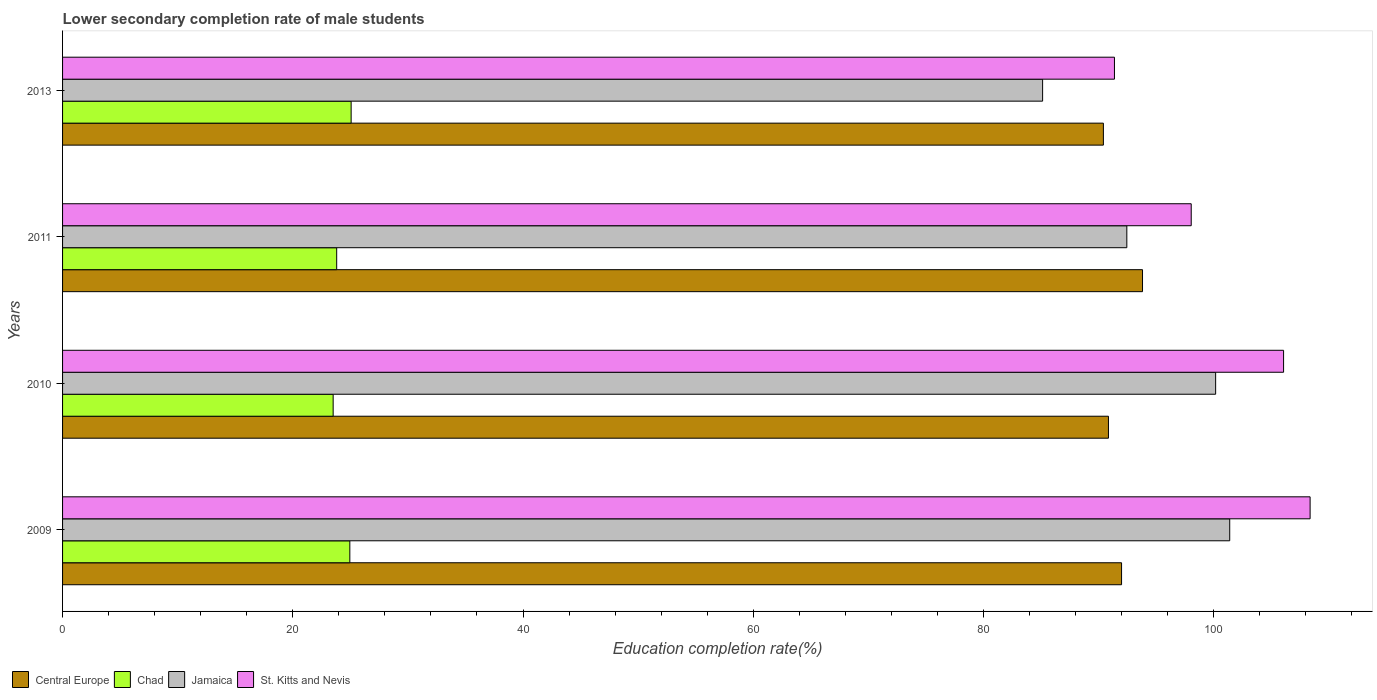How many groups of bars are there?
Your answer should be very brief. 4. How many bars are there on the 4th tick from the top?
Offer a terse response. 4. How many bars are there on the 2nd tick from the bottom?
Offer a very short reply. 4. What is the lower secondary completion rate of male students in St. Kitts and Nevis in 2013?
Keep it short and to the point. 91.38. Across all years, what is the maximum lower secondary completion rate of male students in St. Kitts and Nevis?
Offer a terse response. 108.37. Across all years, what is the minimum lower secondary completion rate of male students in St. Kitts and Nevis?
Keep it short and to the point. 91.38. What is the total lower secondary completion rate of male students in Central Europe in the graph?
Your answer should be compact. 367.07. What is the difference between the lower secondary completion rate of male students in Chad in 2010 and that in 2013?
Make the answer very short. -1.56. What is the difference between the lower secondary completion rate of male students in St. Kitts and Nevis in 2010 and the lower secondary completion rate of male students in Chad in 2009?
Provide a succinct answer. 81.11. What is the average lower secondary completion rate of male students in Chad per year?
Your response must be concise. 24.33. In the year 2009, what is the difference between the lower secondary completion rate of male students in St. Kitts and Nevis and lower secondary completion rate of male students in Chad?
Offer a very short reply. 83.42. What is the ratio of the lower secondary completion rate of male students in St. Kitts and Nevis in 2010 to that in 2011?
Make the answer very short. 1.08. Is the lower secondary completion rate of male students in Chad in 2009 less than that in 2013?
Your answer should be very brief. Yes. What is the difference between the highest and the second highest lower secondary completion rate of male students in Jamaica?
Your response must be concise. 1.22. What is the difference between the highest and the lowest lower secondary completion rate of male students in Chad?
Your answer should be very brief. 1.56. In how many years, is the lower secondary completion rate of male students in Central Europe greater than the average lower secondary completion rate of male students in Central Europe taken over all years?
Make the answer very short. 2. Is it the case that in every year, the sum of the lower secondary completion rate of male students in Central Europe and lower secondary completion rate of male students in Chad is greater than the sum of lower secondary completion rate of male students in St. Kitts and Nevis and lower secondary completion rate of male students in Jamaica?
Give a very brief answer. Yes. What does the 4th bar from the top in 2009 represents?
Provide a short and direct response. Central Europe. What does the 1st bar from the bottom in 2010 represents?
Your answer should be compact. Central Europe. Is it the case that in every year, the sum of the lower secondary completion rate of male students in Jamaica and lower secondary completion rate of male students in Chad is greater than the lower secondary completion rate of male students in St. Kitts and Nevis?
Offer a very short reply. Yes. How many bars are there?
Your answer should be very brief. 16. Are all the bars in the graph horizontal?
Provide a short and direct response. Yes. What is the difference between two consecutive major ticks on the X-axis?
Provide a succinct answer. 20. Does the graph contain any zero values?
Provide a short and direct response. No. Does the graph contain grids?
Provide a succinct answer. No. How many legend labels are there?
Keep it short and to the point. 4. How are the legend labels stacked?
Your answer should be very brief. Horizontal. What is the title of the graph?
Your response must be concise. Lower secondary completion rate of male students. What is the label or title of the X-axis?
Provide a short and direct response. Education completion rate(%). What is the label or title of the Y-axis?
Make the answer very short. Years. What is the Education completion rate(%) in Central Europe in 2009?
Offer a very short reply. 91.99. What is the Education completion rate(%) in Chad in 2009?
Make the answer very short. 24.95. What is the Education completion rate(%) of Jamaica in 2009?
Offer a terse response. 101.39. What is the Education completion rate(%) of St. Kitts and Nevis in 2009?
Keep it short and to the point. 108.37. What is the Education completion rate(%) of Central Europe in 2010?
Your answer should be compact. 90.85. What is the Education completion rate(%) of Chad in 2010?
Offer a very short reply. 23.51. What is the Education completion rate(%) of Jamaica in 2010?
Your answer should be very brief. 100.17. What is the Education completion rate(%) of St. Kitts and Nevis in 2010?
Make the answer very short. 106.07. What is the Education completion rate(%) of Central Europe in 2011?
Keep it short and to the point. 93.81. What is the Education completion rate(%) of Chad in 2011?
Your answer should be very brief. 23.81. What is the Education completion rate(%) of Jamaica in 2011?
Your answer should be compact. 92.45. What is the Education completion rate(%) in St. Kitts and Nevis in 2011?
Ensure brevity in your answer.  98.04. What is the Education completion rate(%) of Central Europe in 2013?
Ensure brevity in your answer.  90.41. What is the Education completion rate(%) in Chad in 2013?
Give a very brief answer. 25.07. What is the Education completion rate(%) in Jamaica in 2013?
Keep it short and to the point. 85.13. What is the Education completion rate(%) of St. Kitts and Nevis in 2013?
Your answer should be very brief. 91.38. Across all years, what is the maximum Education completion rate(%) in Central Europe?
Your answer should be very brief. 93.81. Across all years, what is the maximum Education completion rate(%) in Chad?
Offer a very short reply. 25.07. Across all years, what is the maximum Education completion rate(%) of Jamaica?
Give a very brief answer. 101.39. Across all years, what is the maximum Education completion rate(%) of St. Kitts and Nevis?
Provide a succinct answer. 108.37. Across all years, what is the minimum Education completion rate(%) of Central Europe?
Provide a short and direct response. 90.41. Across all years, what is the minimum Education completion rate(%) in Chad?
Ensure brevity in your answer.  23.51. Across all years, what is the minimum Education completion rate(%) of Jamaica?
Your answer should be very brief. 85.13. Across all years, what is the minimum Education completion rate(%) in St. Kitts and Nevis?
Your response must be concise. 91.38. What is the total Education completion rate(%) of Central Europe in the graph?
Offer a very short reply. 367.07. What is the total Education completion rate(%) of Chad in the graph?
Ensure brevity in your answer.  97.34. What is the total Education completion rate(%) in Jamaica in the graph?
Offer a terse response. 379.14. What is the total Education completion rate(%) in St. Kitts and Nevis in the graph?
Keep it short and to the point. 403.86. What is the difference between the Education completion rate(%) of Central Europe in 2009 and that in 2010?
Make the answer very short. 1.14. What is the difference between the Education completion rate(%) in Chad in 2009 and that in 2010?
Give a very brief answer. 1.45. What is the difference between the Education completion rate(%) of Jamaica in 2009 and that in 2010?
Your answer should be compact. 1.22. What is the difference between the Education completion rate(%) in St. Kitts and Nevis in 2009 and that in 2010?
Offer a very short reply. 2.3. What is the difference between the Education completion rate(%) of Central Europe in 2009 and that in 2011?
Keep it short and to the point. -1.82. What is the difference between the Education completion rate(%) of Chad in 2009 and that in 2011?
Offer a very short reply. 1.14. What is the difference between the Education completion rate(%) of Jamaica in 2009 and that in 2011?
Your answer should be compact. 8.94. What is the difference between the Education completion rate(%) of St. Kitts and Nevis in 2009 and that in 2011?
Ensure brevity in your answer.  10.33. What is the difference between the Education completion rate(%) of Central Europe in 2009 and that in 2013?
Keep it short and to the point. 1.58. What is the difference between the Education completion rate(%) of Chad in 2009 and that in 2013?
Provide a short and direct response. -0.11. What is the difference between the Education completion rate(%) in Jamaica in 2009 and that in 2013?
Give a very brief answer. 16.25. What is the difference between the Education completion rate(%) in St. Kitts and Nevis in 2009 and that in 2013?
Your answer should be compact. 17. What is the difference between the Education completion rate(%) in Central Europe in 2010 and that in 2011?
Keep it short and to the point. -2.96. What is the difference between the Education completion rate(%) in Chad in 2010 and that in 2011?
Give a very brief answer. -0.31. What is the difference between the Education completion rate(%) in Jamaica in 2010 and that in 2011?
Give a very brief answer. 7.71. What is the difference between the Education completion rate(%) in St. Kitts and Nevis in 2010 and that in 2011?
Offer a terse response. 8.02. What is the difference between the Education completion rate(%) of Central Europe in 2010 and that in 2013?
Offer a terse response. 0.44. What is the difference between the Education completion rate(%) in Chad in 2010 and that in 2013?
Keep it short and to the point. -1.56. What is the difference between the Education completion rate(%) of Jamaica in 2010 and that in 2013?
Offer a terse response. 15.03. What is the difference between the Education completion rate(%) of St. Kitts and Nevis in 2010 and that in 2013?
Provide a succinct answer. 14.69. What is the difference between the Education completion rate(%) of Central Europe in 2011 and that in 2013?
Your answer should be very brief. 3.4. What is the difference between the Education completion rate(%) of Chad in 2011 and that in 2013?
Offer a very short reply. -1.26. What is the difference between the Education completion rate(%) of Jamaica in 2011 and that in 2013?
Keep it short and to the point. 7.32. What is the difference between the Education completion rate(%) in St. Kitts and Nevis in 2011 and that in 2013?
Offer a terse response. 6.67. What is the difference between the Education completion rate(%) of Central Europe in 2009 and the Education completion rate(%) of Chad in 2010?
Give a very brief answer. 68.49. What is the difference between the Education completion rate(%) in Central Europe in 2009 and the Education completion rate(%) in Jamaica in 2010?
Give a very brief answer. -8.17. What is the difference between the Education completion rate(%) in Central Europe in 2009 and the Education completion rate(%) in St. Kitts and Nevis in 2010?
Ensure brevity in your answer.  -14.07. What is the difference between the Education completion rate(%) of Chad in 2009 and the Education completion rate(%) of Jamaica in 2010?
Your response must be concise. -75.21. What is the difference between the Education completion rate(%) in Chad in 2009 and the Education completion rate(%) in St. Kitts and Nevis in 2010?
Offer a very short reply. -81.11. What is the difference between the Education completion rate(%) in Jamaica in 2009 and the Education completion rate(%) in St. Kitts and Nevis in 2010?
Your answer should be very brief. -4.68. What is the difference between the Education completion rate(%) of Central Europe in 2009 and the Education completion rate(%) of Chad in 2011?
Give a very brief answer. 68.18. What is the difference between the Education completion rate(%) of Central Europe in 2009 and the Education completion rate(%) of Jamaica in 2011?
Provide a succinct answer. -0.46. What is the difference between the Education completion rate(%) in Central Europe in 2009 and the Education completion rate(%) in St. Kitts and Nevis in 2011?
Your response must be concise. -6.05. What is the difference between the Education completion rate(%) in Chad in 2009 and the Education completion rate(%) in Jamaica in 2011?
Your response must be concise. -67.5. What is the difference between the Education completion rate(%) of Chad in 2009 and the Education completion rate(%) of St. Kitts and Nevis in 2011?
Your response must be concise. -73.09. What is the difference between the Education completion rate(%) in Jamaica in 2009 and the Education completion rate(%) in St. Kitts and Nevis in 2011?
Ensure brevity in your answer.  3.34. What is the difference between the Education completion rate(%) of Central Europe in 2009 and the Education completion rate(%) of Chad in 2013?
Make the answer very short. 66.93. What is the difference between the Education completion rate(%) in Central Europe in 2009 and the Education completion rate(%) in Jamaica in 2013?
Ensure brevity in your answer.  6.86. What is the difference between the Education completion rate(%) of Central Europe in 2009 and the Education completion rate(%) of St. Kitts and Nevis in 2013?
Provide a short and direct response. 0.62. What is the difference between the Education completion rate(%) of Chad in 2009 and the Education completion rate(%) of Jamaica in 2013?
Provide a short and direct response. -60.18. What is the difference between the Education completion rate(%) in Chad in 2009 and the Education completion rate(%) in St. Kitts and Nevis in 2013?
Provide a succinct answer. -66.42. What is the difference between the Education completion rate(%) in Jamaica in 2009 and the Education completion rate(%) in St. Kitts and Nevis in 2013?
Your answer should be compact. 10.01. What is the difference between the Education completion rate(%) in Central Europe in 2010 and the Education completion rate(%) in Chad in 2011?
Give a very brief answer. 67.04. What is the difference between the Education completion rate(%) in Central Europe in 2010 and the Education completion rate(%) in Jamaica in 2011?
Provide a short and direct response. -1.6. What is the difference between the Education completion rate(%) in Central Europe in 2010 and the Education completion rate(%) in St. Kitts and Nevis in 2011?
Make the answer very short. -7.19. What is the difference between the Education completion rate(%) in Chad in 2010 and the Education completion rate(%) in Jamaica in 2011?
Ensure brevity in your answer.  -68.95. What is the difference between the Education completion rate(%) of Chad in 2010 and the Education completion rate(%) of St. Kitts and Nevis in 2011?
Provide a succinct answer. -74.54. What is the difference between the Education completion rate(%) of Jamaica in 2010 and the Education completion rate(%) of St. Kitts and Nevis in 2011?
Your answer should be compact. 2.12. What is the difference between the Education completion rate(%) of Central Europe in 2010 and the Education completion rate(%) of Chad in 2013?
Your response must be concise. 65.79. What is the difference between the Education completion rate(%) of Central Europe in 2010 and the Education completion rate(%) of Jamaica in 2013?
Keep it short and to the point. 5.72. What is the difference between the Education completion rate(%) in Central Europe in 2010 and the Education completion rate(%) in St. Kitts and Nevis in 2013?
Provide a succinct answer. -0.52. What is the difference between the Education completion rate(%) in Chad in 2010 and the Education completion rate(%) in Jamaica in 2013?
Your response must be concise. -61.63. What is the difference between the Education completion rate(%) of Chad in 2010 and the Education completion rate(%) of St. Kitts and Nevis in 2013?
Your response must be concise. -67.87. What is the difference between the Education completion rate(%) of Jamaica in 2010 and the Education completion rate(%) of St. Kitts and Nevis in 2013?
Your response must be concise. 8.79. What is the difference between the Education completion rate(%) of Central Europe in 2011 and the Education completion rate(%) of Chad in 2013?
Your answer should be compact. 68.75. What is the difference between the Education completion rate(%) of Central Europe in 2011 and the Education completion rate(%) of Jamaica in 2013?
Your answer should be compact. 8.68. What is the difference between the Education completion rate(%) of Central Europe in 2011 and the Education completion rate(%) of St. Kitts and Nevis in 2013?
Your response must be concise. 2.44. What is the difference between the Education completion rate(%) in Chad in 2011 and the Education completion rate(%) in Jamaica in 2013?
Provide a succinct answer. -61.32. What is the difference between the Education completion rate(%) in Chad in 2011 and the Education completion rate(%) in St. Kitts and Nevis in 2013?
Keep it short and to the point. -67.56. What is the difference between the Education completion rate(%) in Jamaica in 2011 and the Education completion rate(%) in St. Kitts and Nevis in 2013?
Your answer should be very brief. 1.08. What is the average Education completion rate(%) of Central Europe per year?
Make the answer very short. 91.77. What is the average Education completion rate(%) in Chad per year?
Make the answer very short. 24.33. What is the average Education completion rate(%) in Jamaica per year?
Keep it short and to the point. 94.78. What is the average Education completion rate(%) of St. Kitts and Nevis per year?
Keep it short and to the point. 100.96. In the year 2009, what is the difference between the Education completion rate(%) in Central Europe and Education completion rate(%) in Chad?
Your answer should be very brief. 67.04. In the year 2009, what is the difference between the Education completion rate(%) of Central Europe and Education completion rate(%) of Jamaica?
Offer a terse response. -9.39. In the year 2009, what is the difference between the Education completion rate(%) of Central Europe and Education completion rate(%) of St. Kitts and Nevis?
Your response must be concise. -16.38. In the year 2009, what is the difference between the Education completion rate(%) in Chad and Education completion rate(%) in Jamaica?
Offer a terse response. -76.43. In the year 2009, what is the difference between the Education completion rate(%) in Chad and Education completion rate(%) in St. Kitts and Nevis?
Keep it short and to the point. -83.42. In the year 2009, what is the difference between the Education completion rate(%) in Jamaica and Education completion rate(%) in St. Kitts and Nevis?
Provide a succinct answer. -6.98. In the year 2010, what is the difference between the Education completion rate(%) of Central Europe and Education completion rate(%) of Chad?
Keep it short and to the point. 67.35. In the year 2010, what is the difference between the Education completion rate(%) of Central Europe and Education completion rate(%) of Jamaica?
Make the answer very short. -9.31. In the year 2010, what is the difference between the Education completion rate(%) of Central Europe and Education completion rate(%) of St. Kitts and Nevis?
Ensure brevity in your answer.  -15.21. In the year 2010, what is the difference between the Education completion rate(%) of Chad and Education completion rate(%) of Jamaica?
Give a very brief answer. -76.66. In the year 2010, what is the difference between the Education completion rate(%) in Chad and Education completion rate(%) in St. Kitts and Nevis?
Provide a succinct answer. -82.56. In the year 2010, what is the difference between the Education completion rate(%) in Jamaica and Education completion rate(%) in St. Kitts and Nevis?
Provide a short and direct response. -5.9. In the year 2011, what is the difference between the Education completion rate(%) in Central Europe and Education completion rate(%) in Chad?
Ensure brevity in your answer.  70. In the year 2011, what is the difference between the Education completion rate(%) in Central Europe and Education completion rate(%) in Jamaica?
Your answer should be compact. 1.36. In the year 2011, what is the difference between the Education completion rate(%) of Central Europe and Education completion rate(%) of St. Kitts and Nevis?
Provide a short and direct response. -4.23. In the year 2011, what is the difference between the Education completion rate(%) in Chad and Education completion rate(%) in Jamaica?
Make the answer very short. -68.64. In the year 2011, what is the difference between the Education completion rate(%) in Chad and Education completion rate(%) in St. Kitts and Nevis?
Provide a short and direct response. -74.23. In the year 2011, what is the difference between the Education completion rate(%) of Jamaica and Education completion rate(%) of St. Kitts and Nevis?
Offer a terse response. -5.59. In the year 2013, what is the difference between the Education completion rate(%) in Central Europe and Education completion rate(%) in Chad?
Keep it short and to the point. 65.35. In the year 2013, what is the difference between the Education completion rate(%) in Central Europe and Education completion rate(%) in Jamaica?
Give a very brief answer. 5.28. In the year 2013, what is the difference between the Education completion rate(%) of Central Europe and Education completion rate(%) of St. Kitts and Nevis?
Your answer should be very brief. -0.96. In the year 2013, what is the difference between the Education completion rate(%) in Chad and Education completion rate(%) in Jamaica?
Offer a very short reply. -60.07. In the year 2013, what is the difference between the Education completion rate(%) of Chad and Education completion rate(%) of St. Kitts and Nevis?
Offer a terse response. -66.31. In the year 2013, what is the difference between the Education completion rate(%) of Jamaica and Education completion rate(%) of St. Kitts and Nevis?
Make the answer very short. -6.24. What is the ratio of the Education completion rate(%) in Central Europe in 2009 to that in 2010?
Offer a very short reply. 1.01. What is the ratio of the Education completion rate(%) of Chad in 2009 to that in 2010?
Give a very brief answer. 1.06. What is the ratio of the Education completion rate(%) in Jamaica in 2009 to that in 2010?
Your answer should be compact. 1.01. What is the ratio of the Education completion rate(%) in St. Kitts and Nevis in 2009 to that in 2010?
Keep it short and to the point. 1.02. What is the ratio of the Education completion rate(%) of Central Europe in 2009 to that in 2011?
Provide a succinct answer. 0.98. What is the ratio of the Education completion rate(%) of Chad in 2009 to that in 2011?
Provide a short and direct response. 1.05. What is the ratio of the Education completion rate(%) of Jamaica in 2009 to that in 2011?
Your answer should be very brief. 1.1. What is the ratio of the Education completion rate(%) of St. Kitts and Nevis in 2009 to that in 2011?
Provide a succinct answer. 1.11. What is the ratio of the Education completion rate(%) of Central Europe in 2009 to that in 2013?
Provide a succinct answer. 1.02. What is the ratio of the Education completion rate(%) in Jamaica in 2009 to that in 2013?
Ensure brevity in your answer.  1.19. What is the ratio of the Education completion rate(%) of St. Kitts and Nevis in 2009 to that in 2013?
Make the answer very short. 1.19. What is the ratio of the Education completion rate(%) in Central Europe in 2010 to that in 2011?
Your response must be concise. 0.97. What is the ratio of the Education completion rate(%) of Chad in 2010 to that in 2011?
Ensure brevity in your answer.  0.99. What is the ratio of the Education completion rate(%) in Jamaica in 2010 to that in 2011?
Keep it short and to the point. 1.08. What is the ratio of the Education completion rate(%) in St. Kitts and Nevis in 2010 to that in 2011?
Provide a succinct answer. 1.08. What is the ratio of the Education completion rate(%) in Chad in 2010 to that in 2013?
Offer a terse response. 0.94. What is the ratio of the Education completion rate(%) in Jamaica in 2010 to that in 2013?
Your response must be concise. 1.18. What is the ratio of the Education completion rate(%) in St. Kitts and Nevis in 2010 to that in 2013?
Give a very brief answer. 1.16. What is the ratio of the Education completion rate(%) of Central Europe in 2011 to that in 2013?
Provide a succinct answer. 1.04. What is the ratio of the Education completion rate(%) in Chad in 2011 to that in 2013?
Your answer should be very brief. 0.95. What is the ratio of the Education completion rate(%) in Jamaica in 2011 to that in 2013?
Your response must be concise. 1.09. What is the ratio of the Education completion rate(%) in St. Kitts and Nevis in 2011 to that in 2013?
Offer a very short reply. 1.07. What is the difference between the highest and the second highest Education completion rate(%) in Central Europe?
Provide a short and direct response. 1.82. What is the difference between the highest and the second highest Education completion rate(%) in Chad?
Provide a succinct answer. 0.11. What is the difference between the highest and the second highest Education completion rate(%) in Jamaica?
Ensure brevity in your answer.  1.22. What is the difference between the highest and the second highest Education completion rate(%) in St. Kitts and Nevis?
Your answer should be compact. 2.3. What is the difference between the highest and the lowest Education completion rate(%) in Central Europe?
Provide a succinct answer. 3.4. What is the difference between the highest and the lowest Education completion rate(%) of Chad?
Make the answer very short. 1.56. What is the difference between the highest and the lowest Education completion rate(%) of Jamaica?
Make the answer very short. 16.25. What is the difference between the highest and the lowest Education completion rate(%) in St. Kitts and Nevis?
Offer a terse response. 17. 